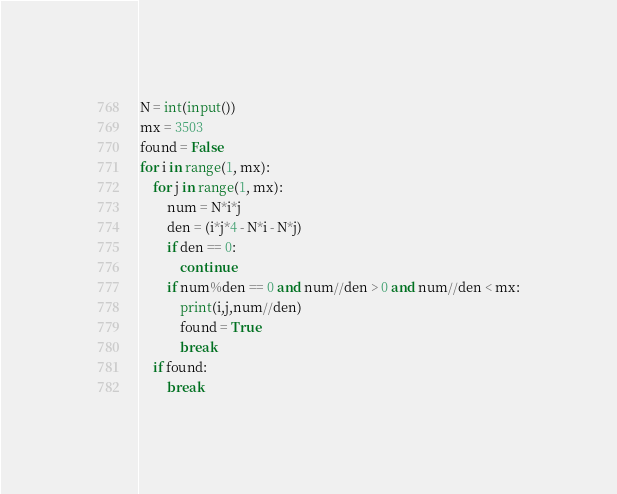Convert code to text. <code><loc_0><loc_0><loc_500><loc_500><_Python_>N = int(input())
mx = 3503
found = False
for i in range(1, mx):
    for j in range(1, mx):
        num = N*i*j
        den = (i*j*4 - N*i - N*j)
        if den == 0:
            continue
        if num%den == 0 and num//den > 0 and num//den < mx:
            print(i,j,num//den)
            found = True
            break
    if found:
        break</code> 